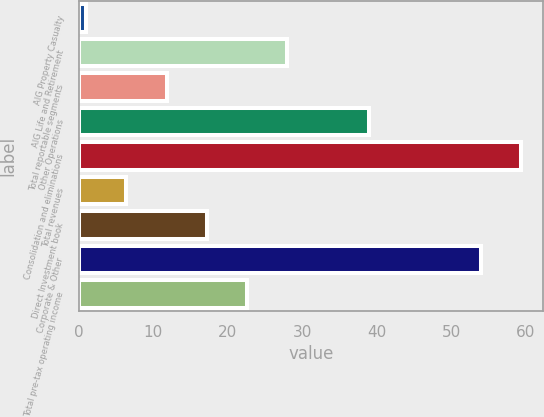<chart> <loc_0><loc_0><loc_500><loc_500><bar_chart><fcel>AIG Property Casualty<fcel>AIG Life and Retirement<fcel>Total reportable segments<fcel>Other Operations<fcel>Consolidation and eliminations<fcel>Total revenues<fcel>Direct Investment book<fcel>Corporate & Other<fcel>Total pre-tax operating income<nl><fcel>1<fcel>28<fcel>11.8<fcel>39<fcel>59.4<fcel>6.4<fcel>17.2<fcel>54<fcel>22.6<nl></chart> 